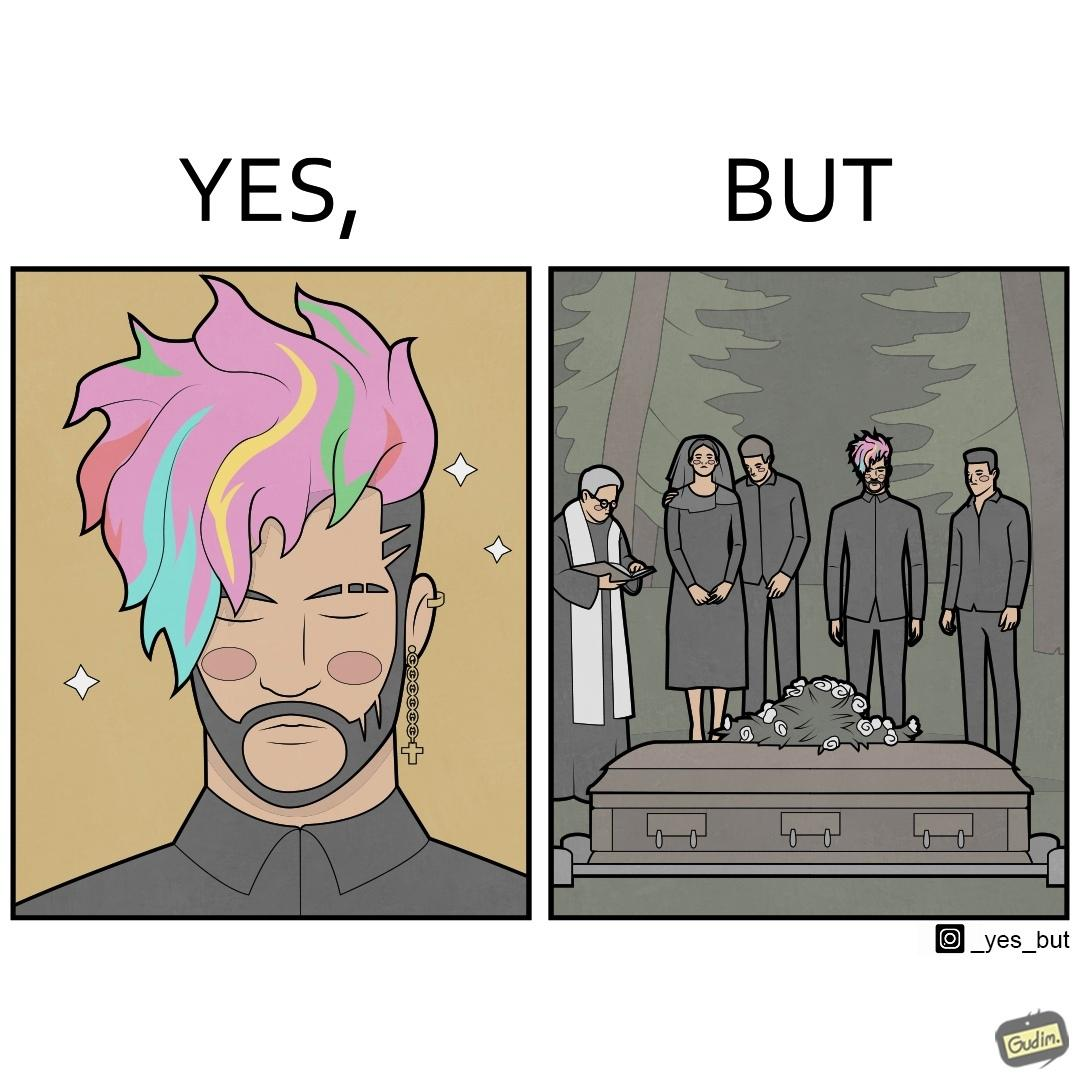Would you classify this image as satirical? Yes, this image is satirical. 